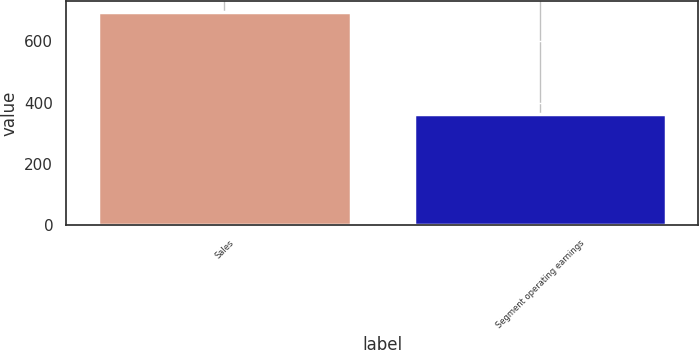Convert chart. <chart><loc_0><loc_0><loc_500><loc_500><bar_chart><fcel>Sales<fcel>Segment operating earnings<nl><fcel>696.2<fcel>361.7<nl></chart> 